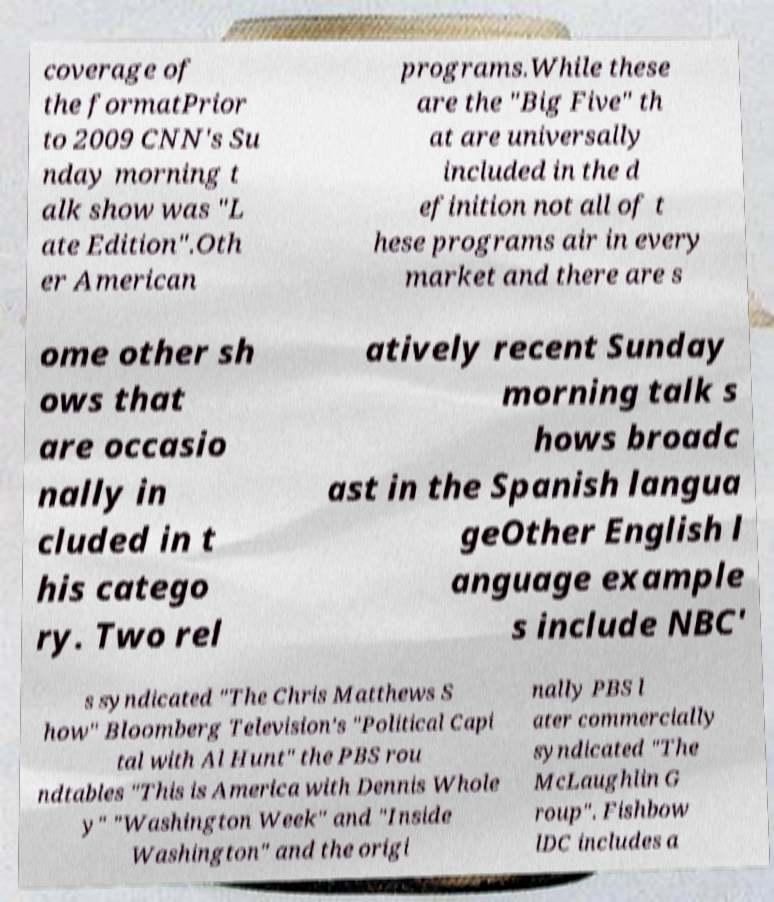Please read and relay the text visible in this image. What does it say? coverage of the formatPrior to 2009 CNN's Su nday morning t alk show was "L ate Edition".Oth er American programs.While these are the "Big Five" th at are universally included in the d efinition not all of t hese programs air in every market and there are s ome other sh ows that are occasio nally in cluded in t his catego ry. Two rel atively recent Sunday morning talk s hows broadc ast in the Spanish langua geOther English l anguage example s include NBC' s syndicated "The Chris Matthews S how" Bloomberg Television's "Political Capi tal with Al Hunt" the PBS rou ndtables "This is America with Dennis Whole y" "Washington Week" and "Inside Washington" and the origi nally PBS l ater commercially syndicated "The McLaughlin G roup". Fishbow lDC includes a 